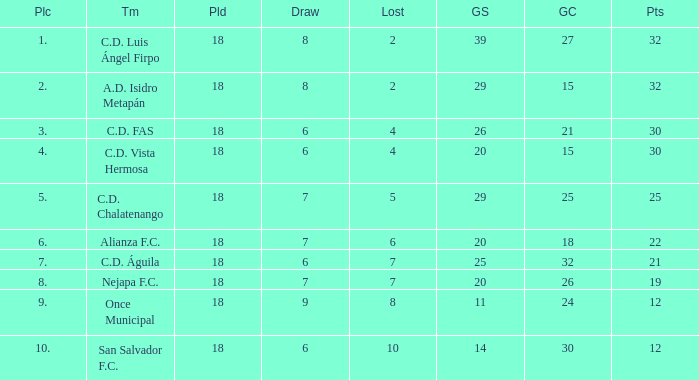What is the total number for a place with points smaller than 12? 0.0. 